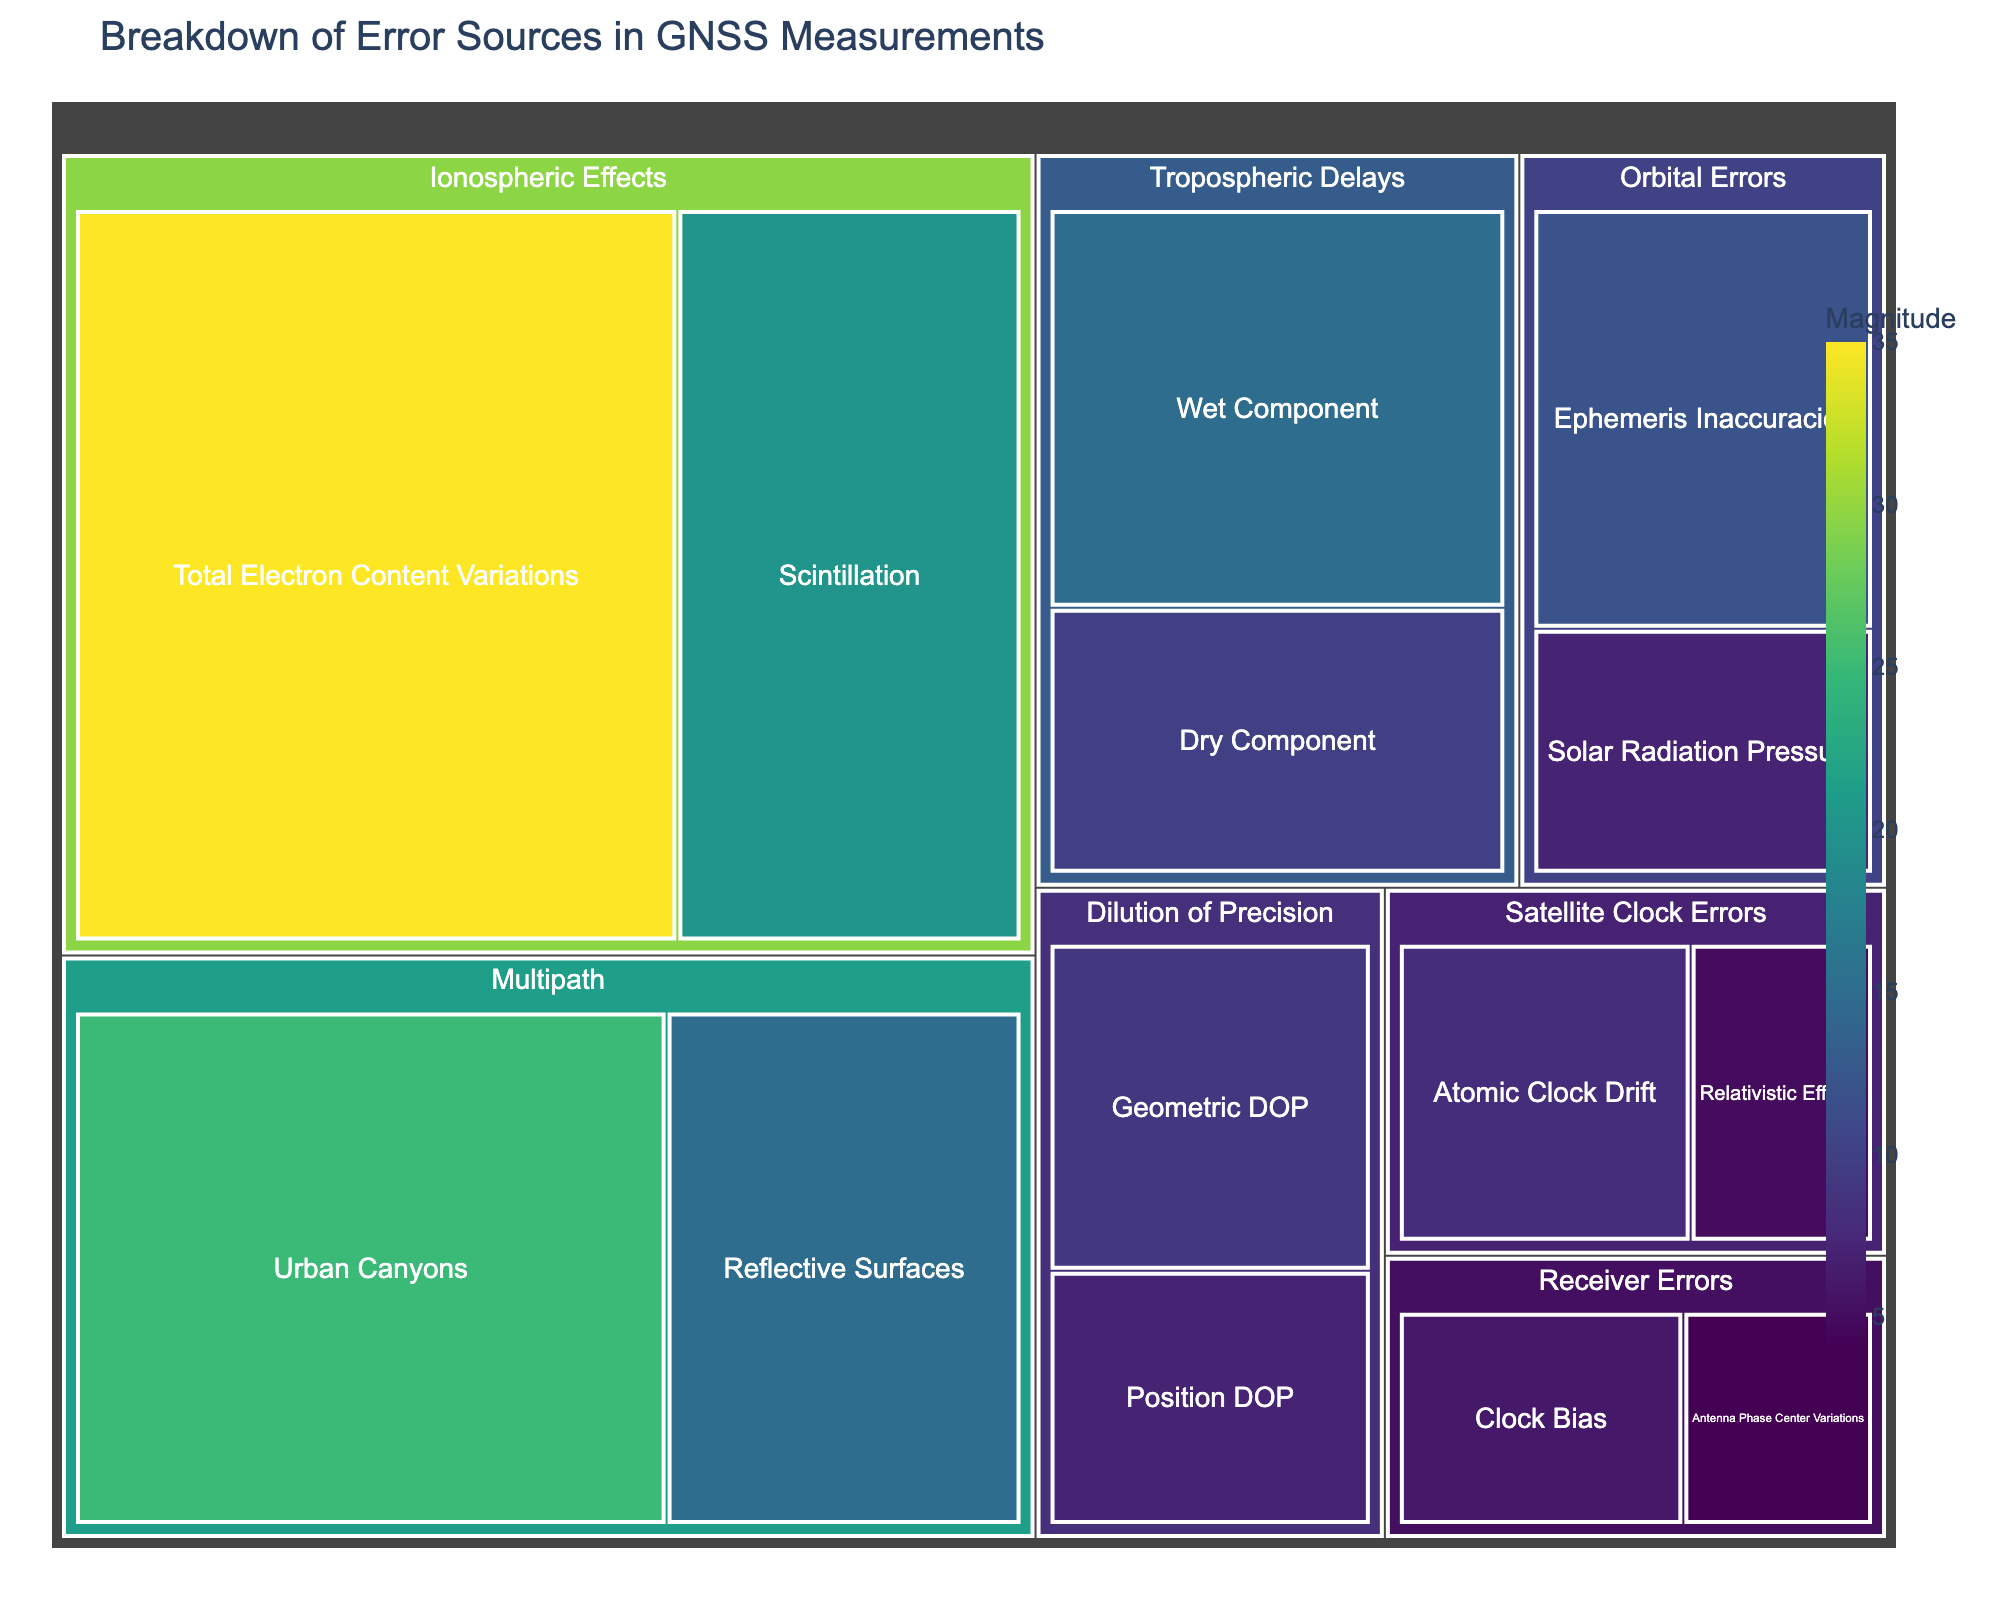Which category contributes the most to GNSS measurement errors? The largest segment in the treemap represents 'Ionospheric Effects'. The size and magnitude of segments in a treemap visualize contribution levels. 'Ionospheric Effects' has the largest combined area, signifying it contributes the most.
Answer: Ionospheric Effects What's the magnitude of Urban Canyons error in Multipath? Locate the 'Multipath' category in the treemap, then find the 'Urban Canyons' subcategory. The value associated with it is 25.
Answer: 25 What is the combined magnitude of errors from 'Satellite Clock Errors'? Identify the segments under 'Satellite Clock Errors', which are 'Atomic Clock Drift' and 'Relativistic Effects'. Adding their values: 8 (Atomic Clock Drift) + 5 (Relativistic Effects) = 13.
Answer: 13 Which has a higher magnitude: Total Electron Content Variations or Wet Component? Compare the segments for 'Total Electron Content Variations' (35) and 'Wet Component' (15). 35 is greater than 15.
Answer: Total Electron Content Variations What's the title of the treemap? Look at the top of the treemap to read the title, which is “Breakdown of Error Sources in GNSS Measurements”.
Answer: Breakdown of Error Sources in GNSS Measurements Is Dry Component larger than Ephemeris Inaccuracies? Compare the values: Dry Component is 10, and Ephemeris Inaccuracies is 12. 10 is less than 12.
Answer: No What is the value for Clock Bias in Receiver Errors? Find the 'Receiver Errors' category, and within it, locate 'Clock Bias'. The value given is 6.
Answer: 6 Which subcategory in Multipath has a smaller error, Urban Canyons or Reflective Surfaces? Within 'Multipath', compare 'Urban Canyons' (25) and 'Reflective Surfaces' (15). 15 is smaller than 25.
Answer: Reflective Surfaces What is the average magnitude of the subcategories in Dilution of Precision? Identify the subcategories: 'Geometric DOP' (9) and 'Position DOP' (7). Calculate the average: (9 + 7) / 2 = 8.
Answer: 8 What’s the combined magnitude of errors related to atmospheric effects (both Ionospheric and Tropospheric)? Add values for all subcategories of 'Ionospheric Effects' (35 + 20 = 55) and 'Tropospheric Delays' (15 + 10 = 25), then sum both: 55 + 25 = 80.
Answer: 80 